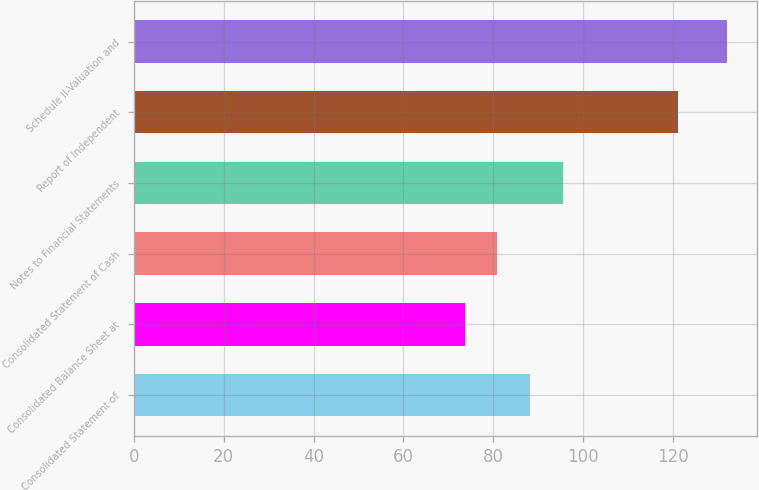Convert chart. <chart><loc_0><loc_0><loc_500><loc_500><bar_chart><fcel>Consolidated Statement of<fcel>Consolidated Balance Sheet at<fcel>Consolidated Statement of Cash<fcel>Notes to Financial Statements<fcel>Report of Independent<fcel>Schedule II-Valuation and<nl><fcel>88.2<fcel>73.6<fcel>80.9<fcel>95.5<fcel>121<fcel>132<nl></chart> 